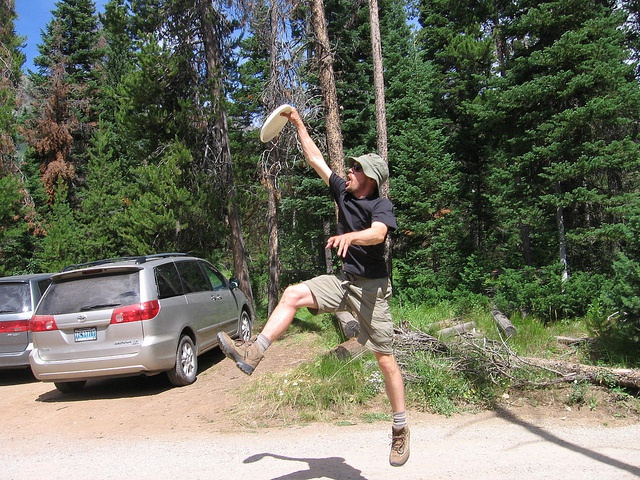Describe the objects in this image and their specific colors. I can see car in black, darkgray, gray, and lightgray tones, people in black, gray, lightgray, and tan tones, car in black, gray, and lavender tones, and frisbee in black, tan, and white tones in this image. 